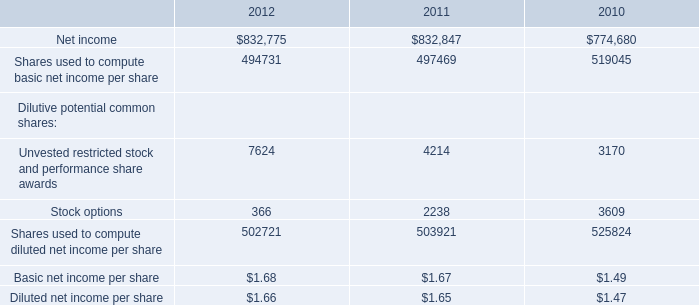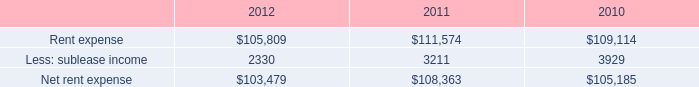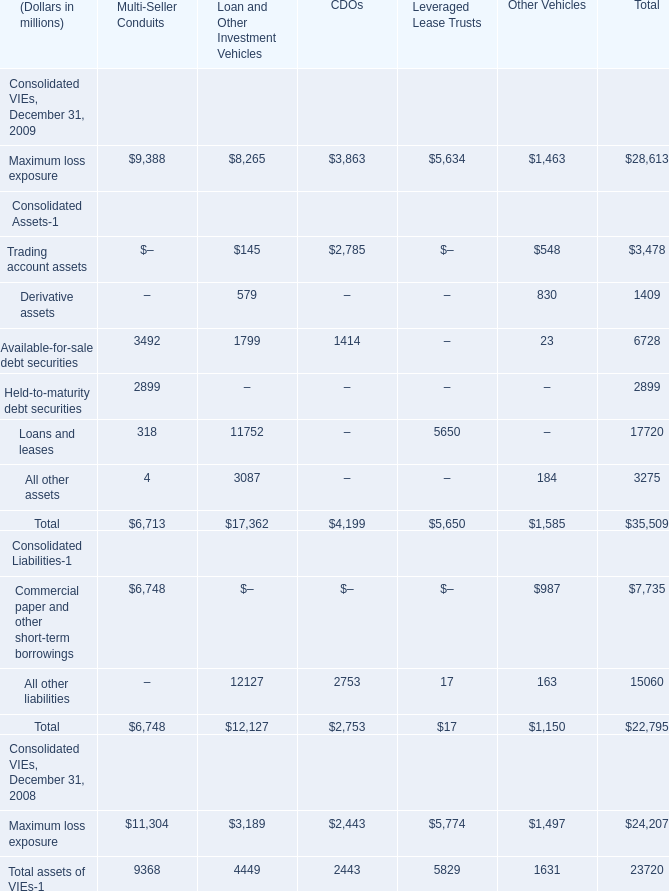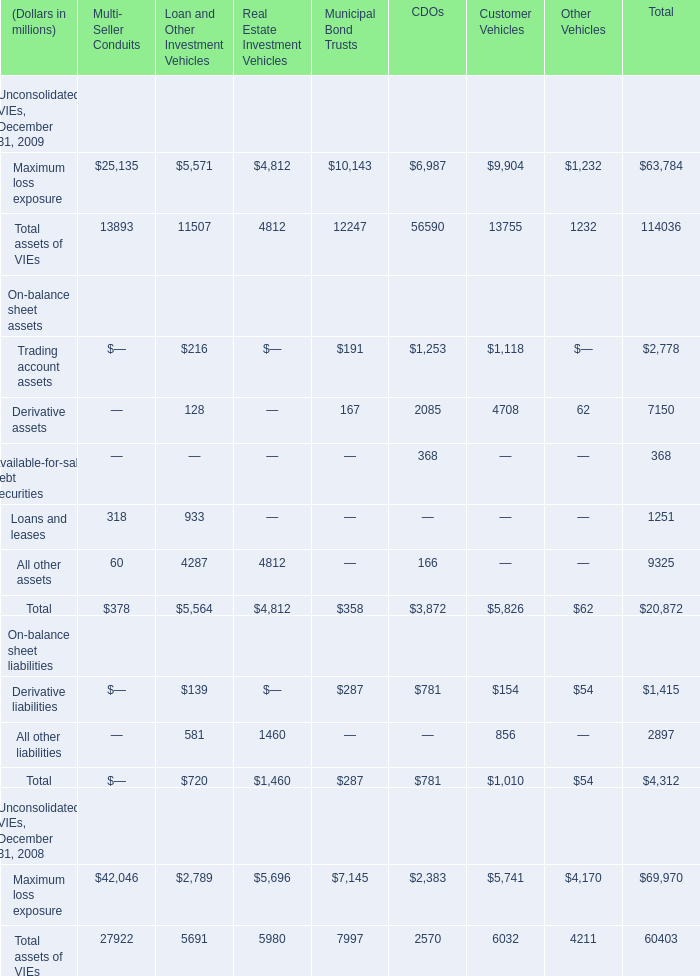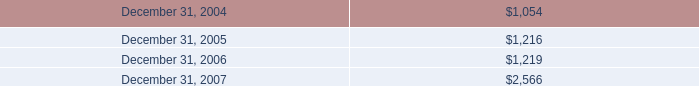What is the average amount of Maximum loss exposure Unconsolidated VIEs, December 31, 2008 of CDOs, and Rent expense of 2010 ? 
Computations: ((2383.0 + 109114.0) / 2)
Answer: 55748.5. 